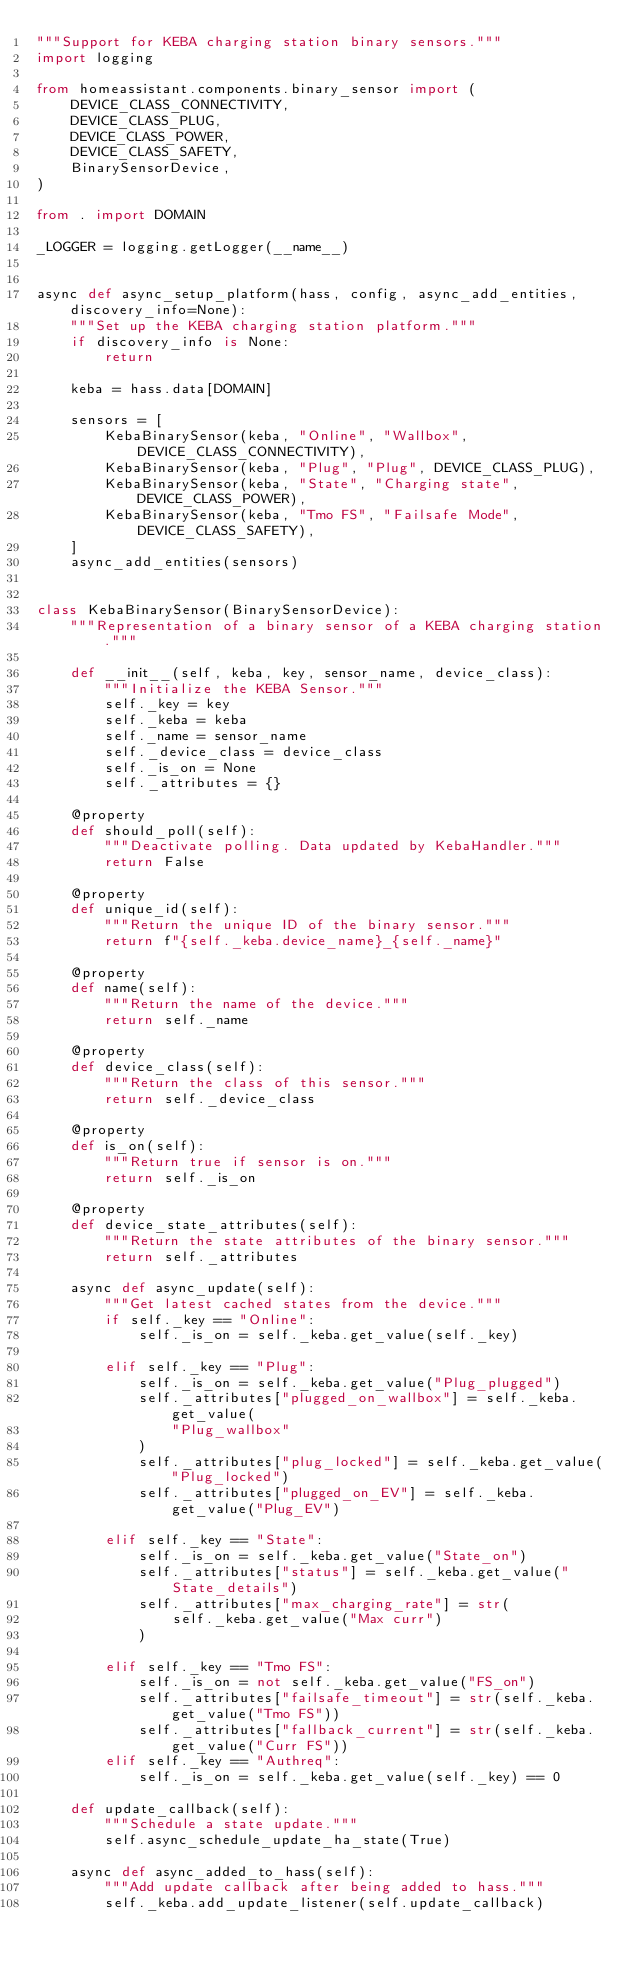<code> <loc_0><loc_0><loc_500><loc_500><_Python_>"""Support for KEBA charging station binary sensors."""
import logging

from homeassistant.components.binary_sensor import (
    DEVICE_CLASS_CONNECTIVITY,
    DEVICE_CLASS_PLUG,
    DEVICE_CLASS_POWER,
    DEVICE_CLASS_SAFETY,
    BinarySensorDevice,
)

from . import DOMAIN

_LOGGER = logging.getLogger(__name__)


async def async_setup_platform(hass, config, async_add_entities, discovery_info=None):
    """Set up the KEBA charging station platform."""
    if discovery_info is None:
        return

    keba = hass.data[DOMAIN]

    sensors = [
        KebaBinarySensor(keba, "Online", "Wallbox", DEVICE_CLASS_CONNECTIVITY),
        KebaBinarySensor(keba, "Plug", "Plug", DEVICE_CLASS_PLUG),
        KebaBinarySensor(keba, "State", "Charging state", DEVICE_CLASS_POWER),
        KebaBinarySensor(keba, "Tmo FS", "Failsafe Mode", DEVICE_CLASS_SAFETY),
    ]
    async_add_entities(sensors)


class KebaBinarySensor(BinarySensorDevice):
    """Representation of a binary sensor of a KEBA charging station."""

    def __init__(self, keba, key, sensor_name, device_class):
        """Initialize the KEBA Sensor."""
        self._key = key
        self._keba = keba
        self._name = sensor_name
        self._device_class = device_class
        self._is_on = None
        self._attributes = {}

    @property
    def should_poll(self):
        """Deactivate polling. Data updated by KebaHandler."""
        return False

    @property
    def unique_id(self):
        """Return the unique ID of the binary sensor."""
        return f"{self._keba.device_name}_{self._name}"

    @property
    def name(self):
        """Return the name of the device."""
        return self._name

    @property
    def device_class(self):
        """Return the class of this sensor."""
        return self._device_class

    @property
    def is_on(self):
        """Return true if sensor is on."""
        return self._is_on

    @property
    def device_state_attributes(self):
        """Return the state attributes of the binary sensor."""
        return self._attributes

    async def async_update(self):
        """Get latest cached states from the device."""
        if self._key == "Online":
            self._is_on = self._keba.get_value(self._key)

        elif self._key == "Plug":
            self._is_on = self._keba.get_value("Plug_plugged")
            self._attributes["plugged_on_wallbox"] = self._keba.get_value(
                "Plug_wallbox"
            )
            self._attributes["plug_locked"] = self._keba.get_value("Plug_locked")
            self._attributes["plugged_on_EV"] = self._keba.get_value("Plug_EV")

        elif self._key == "State":
            self._is_on = self._keba.get_value("State_on")
            self._attributes["status"] = self._keba.get_value("State_details")
            self._attributes["max_charging_rate"] = str(
                self._keba.get_value("Max curr")
            )

        elif self._key == "Tmo FS":
            self._is_on = not self._keba.get_value("FS_on")
            self._attributes["failsafe_timeout"] = str(self._keba.get_value("Tmo FS"))
            self._attributes["fallback_current"] = str(self._keba.get_value("Curr FS"))
        elif self._key == "Authreq":
            self._is_on = self._keba.get_value(self._key) == 0

    def update_callback(self):
        """Schedule a state update."""
        self.async_schedule_update_ha_state(True)

    async def async_added_to_hass(self):
        """Add update callback after being added to hass."""
        self._keba.add_update_listener(self.update_callback)
</code> 